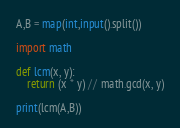Convert code to text. <code><loc_0><loc_0><loc_500><loc_500><_Python_>A,B = map(int,input().split())

import math

def lcm(x, y):
    return (x * y) // math.gcd(x, y)

print(lcm(A,B))</code> 